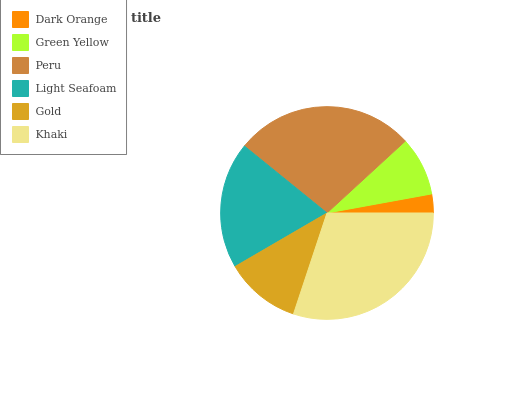Is Dark Orange the minimum?
Answer yes or no. Yes. Is Khaki the maximum?
Answer yes or no. Yes. Is Green Yellow the minimum?
Answer yes or no. No. Is Green Yellow the maximum?
Answer yes or no. No. Is Green Yellow greater than Dark Orange?
Answer yes or no. Yes. Is Dark Orange less than Green Yellow?
Answer yes or no. Yes. Is Dark Orange greater than Green Yellow?
Answer yes or no. No. Is Green Yellow less than Dark Orange?
Answer yes or no. No. Is Light Seafoam the high median?
Answer yes or no. Yes. Is Gold the low median?
Answer yes or no. Yes. Is Gold the high median?
Answer yes or no. No. Is Peru the low median?
Answer yes or no. No. 